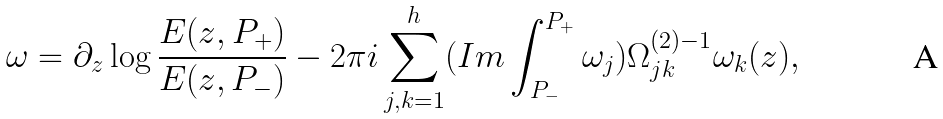Convert formula to latex. <formula><loc_0><loc_0><loc_500><loc_500>\omega = \partial _ { z } \log \frac { E ( z , P _ { + } ) } { E ( z , P _ { - } ) } - 2 \pi i \sum _ { j , k = 1 } ^ { h } ( I m \int _ { P _ { - } } ^ { P _ { + } } \omega _ { j } ) \Omega _ { j k } ^ { ( 2 ) - 1 } \omega _ { k } ( z ) ,</formula> 